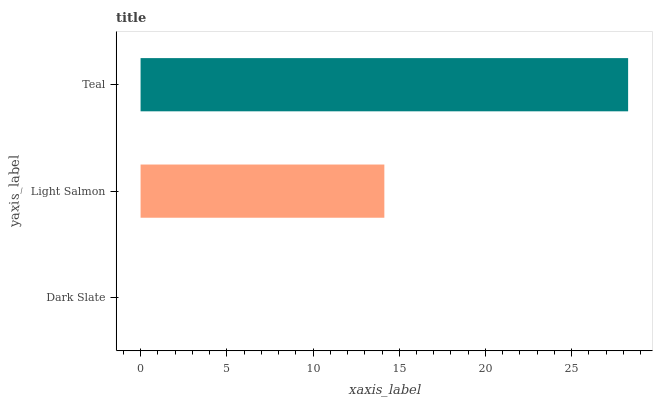Is Dark Slate the minimum?
Answer yes or no. Yes. Is Teal the maximum?
Answer yes or no. Yes. Is Light Salmon the minimum?
Answer yes or no. No. Is Light Salmon the maximum?
Answer yes or no. No. Is Light Salmon greater than Dark Slate?
Answer yes or no. Yes. Is Dark Slate less than Light Salmon?
Answer yes or no. Yes. Is Dark Slate greater than Light Salmon?
Answer yes or no. No. Is Light Salmon less than Dark Slate?
Answer yes or no. No. Is Light Salmon the high median?
Answer yes or no. Yes. Is Light Salmon the low median?
Answer yes or no. Yes. Is Teal the high median?
Answer yes or no. No. Is Dark Slate the low median?
Answer yes or no. No. 